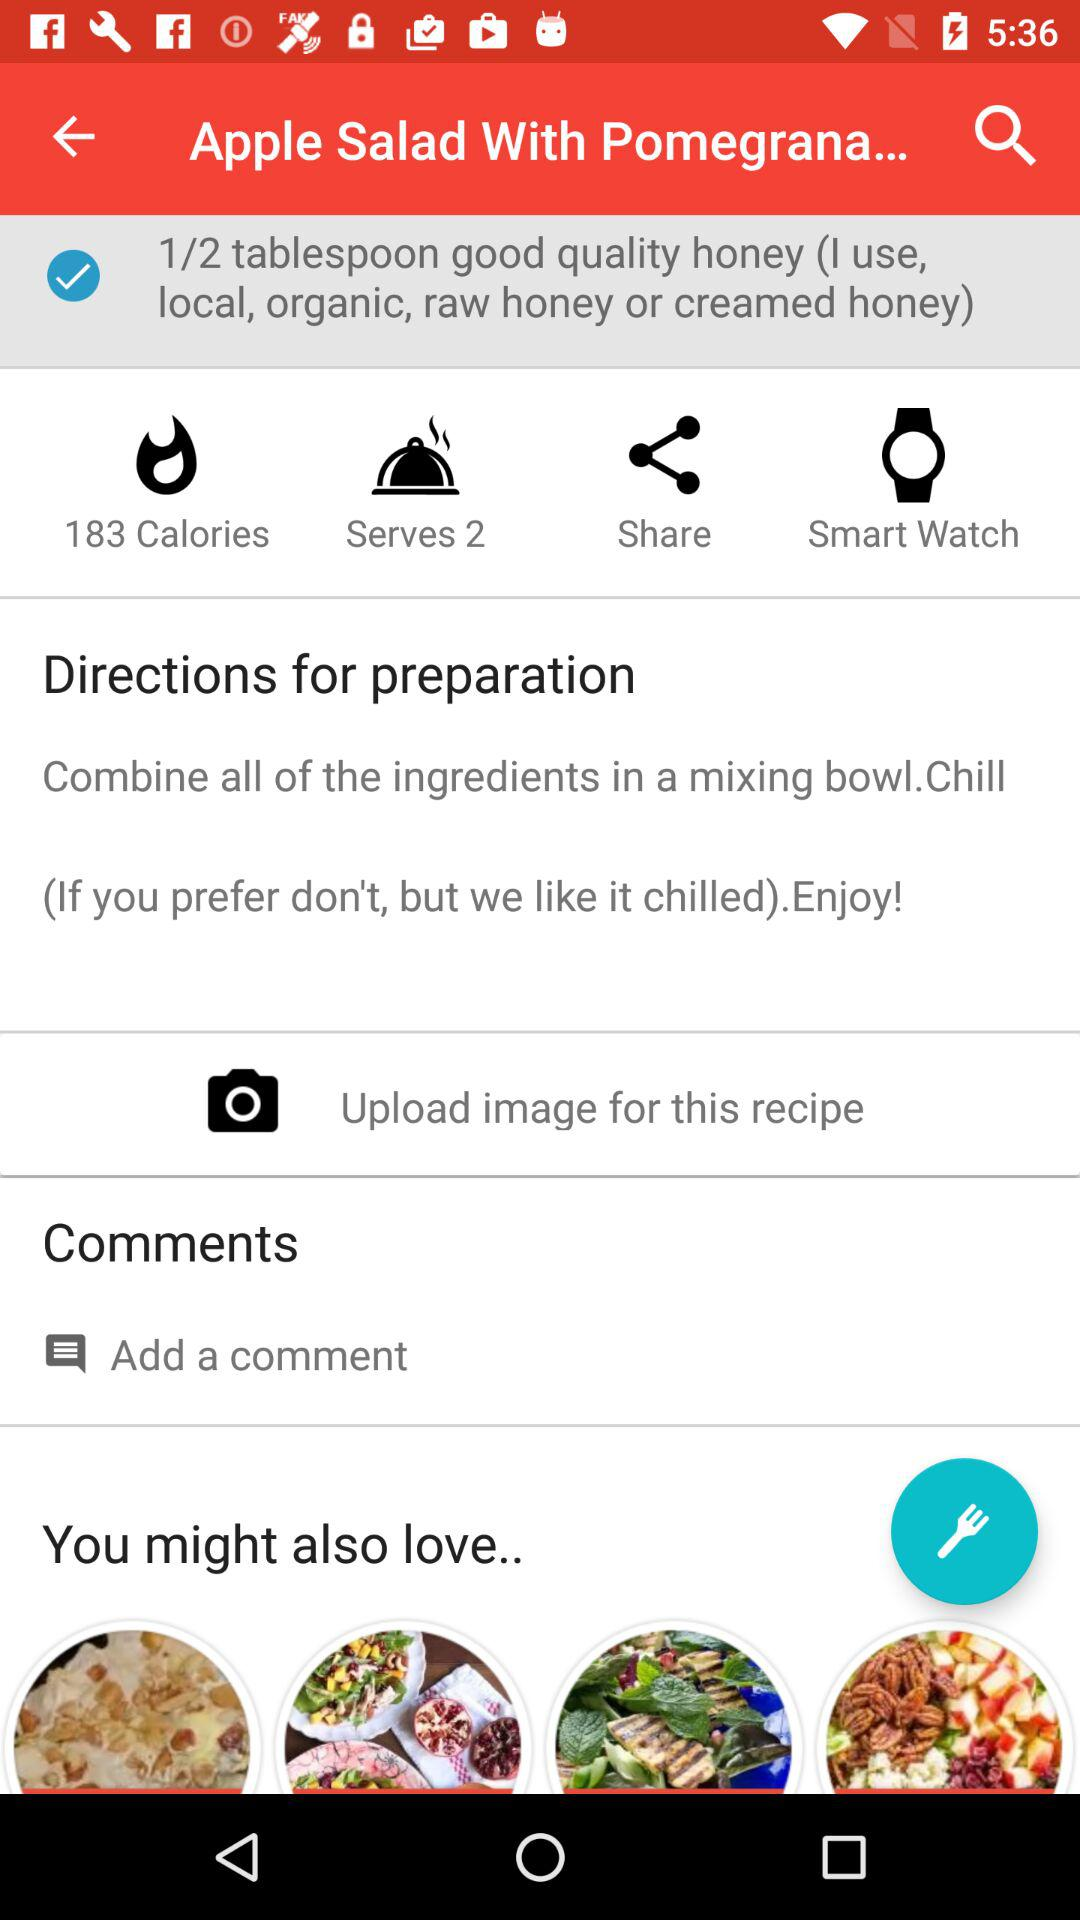How many people can the dish be served to? It can be served to 2 people. 